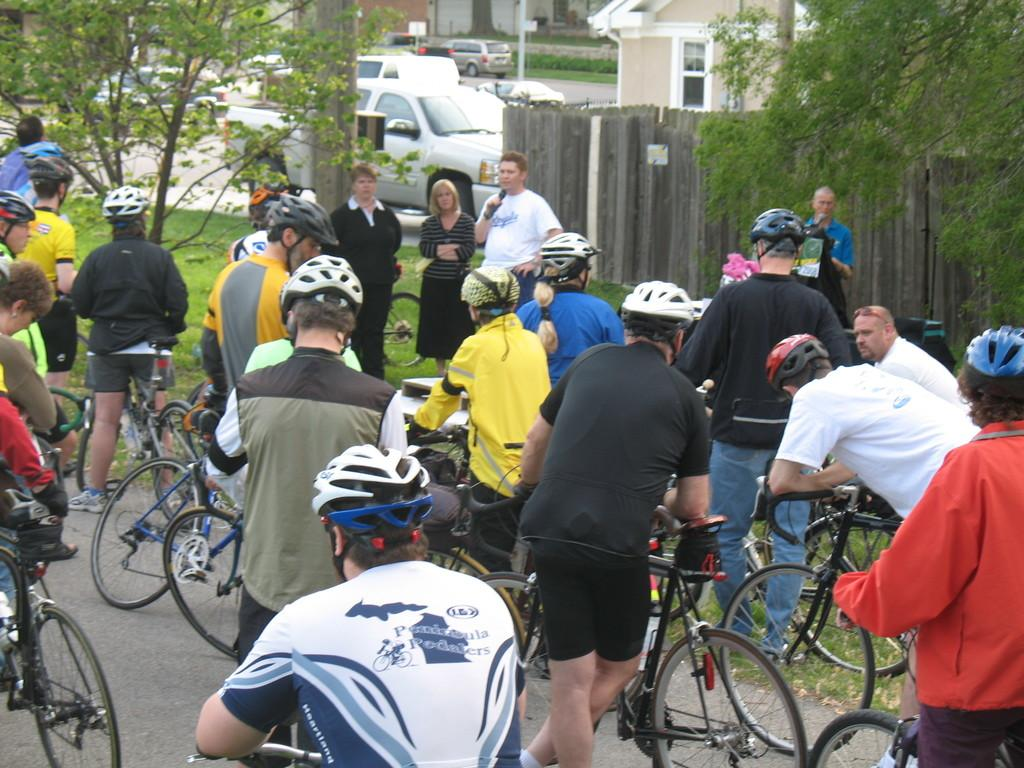Who is present in the image? There are people in the image. What are the people wearing? The people are wearing helmets. What objects are associated with the people in the image? There are bicycles in the image, and the people are standing with the bicycles. Where is the scene taking place? The scene takes place on a road. What can be seen in the background of the image? There are trees, wooden fencing, cars on the road, and buildings in the background of the image. What type of friends are depicted in the image? There is no mention of friends in the image; it features people wearing helmets and standing with bicycles on a road. 